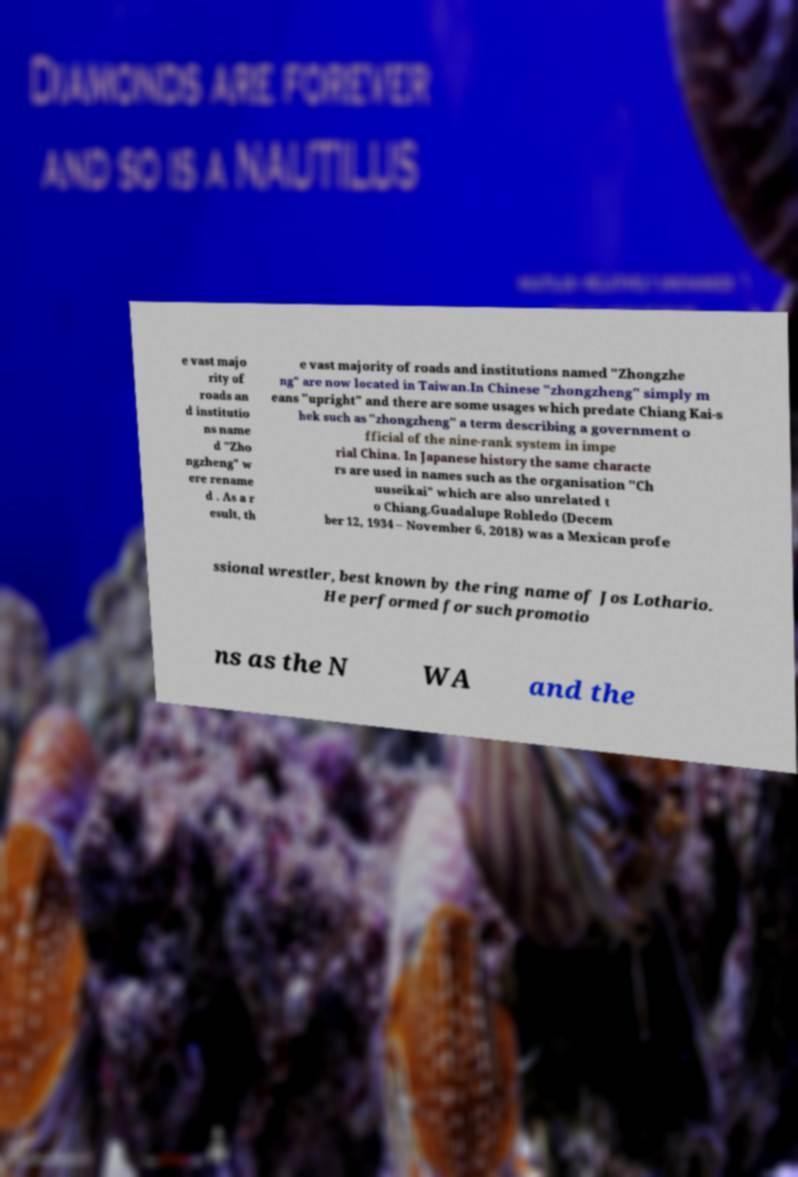Can you read and provide the text displayed in the image?This photo seems to have some interesting text. Can you extract and type it out for me? e vast majo rity of roads an d institutio ns name d "Zho ngzheng" w ere rename d . As a r esult, th e vast majority of roads and institutions named "Zhongzhe ng" are now located in Taiwan.In Chinese "zhongzheng" simply m eans "upright" and there are some usages which predate Chiang Kai-s hek such as "zhongzheng" a term describing a government o fficial of the nine-rank system in impe rial China. In Japanese history the same characte rs are used in names such as the organisation "Ch uuseikai" which are also unrelated t o Chiang.Guadalupe Robledo (Decem ber 12, 1934 – November 6, 2018) was a Mexican profe ssional wrestler, best known by the ring name of Jos Lothario. He performed for such promotio ns as the N WA and the 